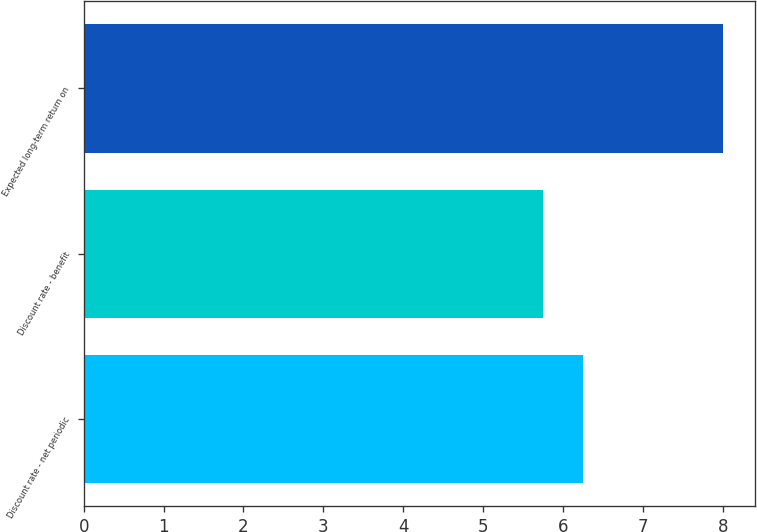<chart> <loc_0><loc_0><loc_500><loc_500><bar_chart><fcel>Discount rate - net periodic<fcel>Discount rate - benefit<fcel>Expected long-term return on<nl><fcel>6.25<fcel>5.75<fcel>8<nl></chart> 